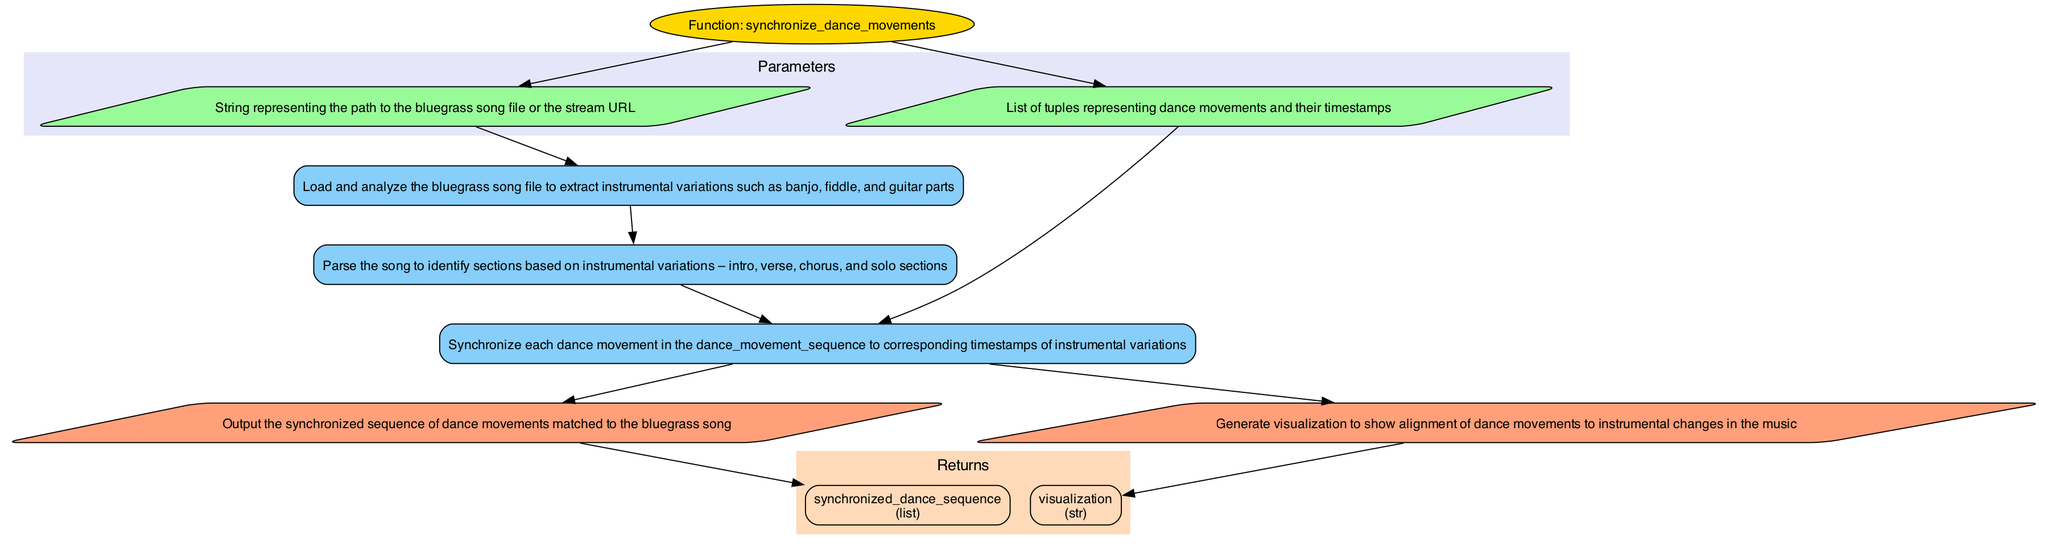What is the name of the function depicted in the diagram? The function name is clearly labeled at the top of the flowchart, specified as "synchronize_dance_movements."
Answer: synchronize_dance_movements How many input parameters are there in this function? Two input parameters are shown: "bluegrass_song" and "dance_movement_sequence," indicated in the Parameters section of the diagram.
Answer: 2 What is the output of the function? The function has two outputs, "synchronized_dance_sequence" and "visualization," marked in the Returns section of the diagram.
Answer: 2 Which process immediately follows loading the bluegrass song? The process that immediately follows is "extract_instrumental_structure," connected directly by an edge from "load_bluegrass_song."
Answer: extract_instrumental_structure What do the arrows represent in this flowchart? The arrows in the flowchart represent the flow of information between different processes and outputs, showing the sequence of operations executed in the function.
Answer: Flow of information How are dance movements synchronized to the music? Dance movements are synchronized in the "map_dance_to_music" process, which connects both the "dance_movement_sequence" input and proceeds to produce the outputs.
Answer: map_dance_to_music What type of node represents the output "visualization"? The output "visualization" is represented as a parallelogram style node, indicating it’s an output result of the function as shown in the Return section.
Answer: Parallelogram How does the function handle the input "dance_movement_sequence"? The function directly connects the "dance_movement_sequence" input to the "map_dance_to_music" process, indicating it is used to synchronize the movements.
Answer: map_dance_to_music What color represents the process nodes in this flowchart? Process nodes in this diagram are filled with a light blue color (87CEFA), ensuring they are visually distinct from input and output nodes.
Answer: Light blue 